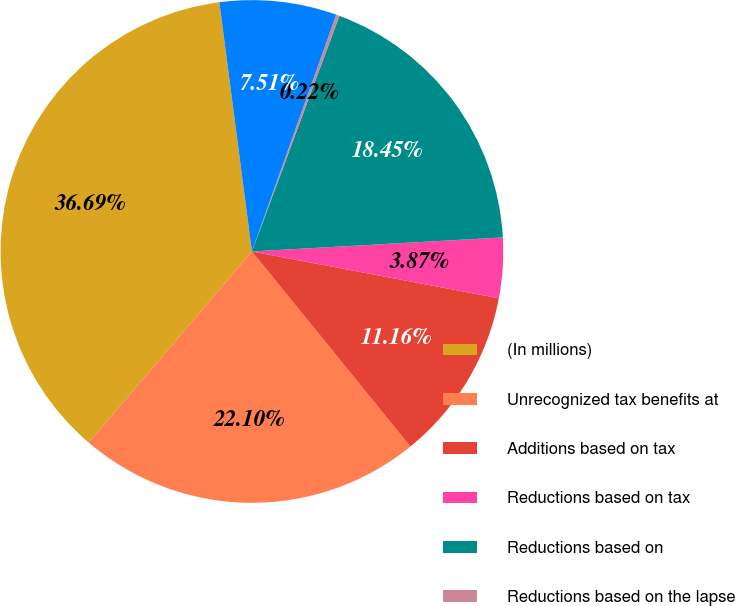<chart> <loc_0><loc_0><loc_500><loc_500><pie_chart><fcel>(In millions)<fcel>Unrecognized tax benefits at<fcel>Additions based on tax<fcel>Reductions based on tax<fcel>Reductions based on<fcel>Reductions based on the lapse<fcel>Exchange rate fluctuations<nl><fcel>36.69%<fcel>22.1%<fcel>11.16%<fcel>3.87%<fcel>18.45%<fcel>0.22%<fcel>7.51%<nl></chart> 